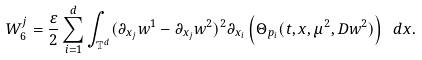<formula> <loc_0><loc_0><loc_500><loc_500>W _ { 6 } ^ { j } = \frac { \varepsilon } { 2 } \sum _ { i = 1 } ^ { d } \int _ { \mathbb { T } ^ { d } } ( \partial _ { x _ { j } } w ^ { 1 } - \partial _ { x _ { j } } w ^ { 2 } ) ^ { 2 } \partial _ { x _ { i } } \left ( \Theta _ { p _ { i } } ( t , x , \mu ^ { 2 } , D w ^ { 2 } ) \right ) \ d x .</formula> 